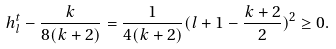Convert formula to latex. <formula><loc_0><loc_0><loc_500><loc_500>h _ { l } ^ { t } - \frac { k } { 8 ( k + 2 ) } = \frac { 1 } { 4 ( k + 2 ) } ( l + 1 - \frac { k + 2 } { 2 } ) ^ { 2 } \geq 0 .</formula> 